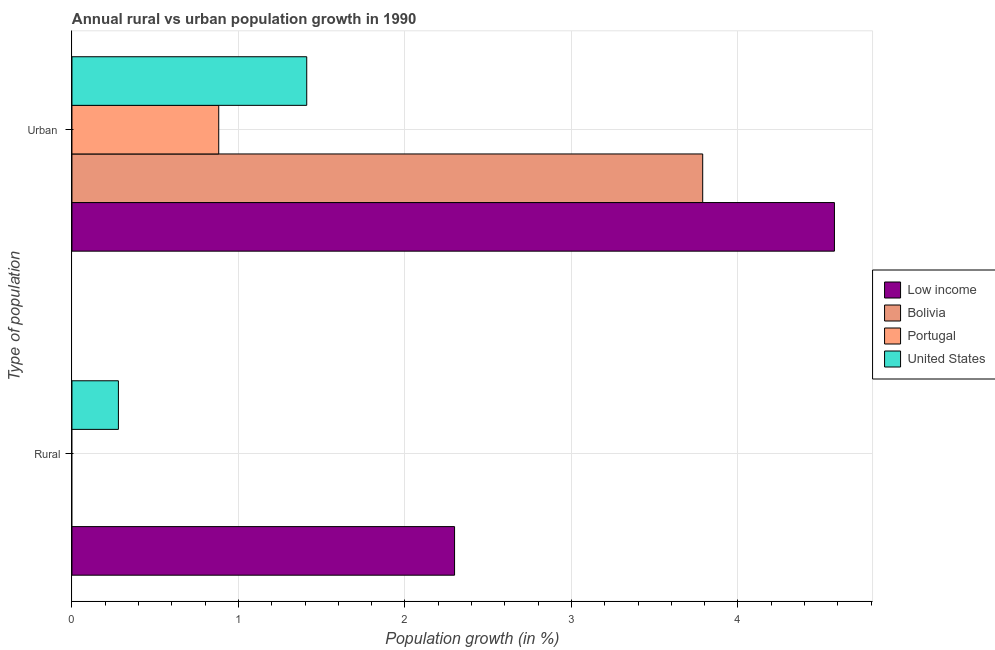Are the number of bars per tick equal to the number of legend labels?
Give a very brief answer. No. Are the number of bars on each tick of the Y-axis equal?
Your answer should be very brief. No. What is the label of the 1st group of bars from the top?
Provide a short and direct response. Urban . Across all countries, what is the maximum urban population growth?
Make the answer very short. 4.58. Across all countries, what is the minimum urban population growth?
Ensure brevity in your answer.  0.88. What is the total urban population growth in the graph?
Make the answer very short. 10.66. What is the difference between the urban population growth in Low income and that in Portugal?
Your answer should be very brief. 3.7. What is the difference between the rural population growth in Bolivia and the urban population growth in Portugal?
Keep it short and to the point. -0.88. What is the average rural population growth per country?
Keep it short and to the point. 0.64. What is the difference between the rural population growth and urban population growth in Low income?
Offer a terse response. -2.28. In how many countries, is the rural population growth greater than 4.4 %?
Make the answer very short. 0. What is the ratio of the urban population growth in Portugal to that in Low income?
Offer a terse response. 0.19. In how many countries, is the urban population growth greater than the average urban population growth taken over all countries?
Offer a very short reply. 2. How many bars are there?
Give a very brief answer. 6. Are all the bars in the graph horizontal?
Offer a terse response. Yes. Are the values on the major ticks of X-axis written in scientific E-notation?
Your response must be concise. No. Does the graph contain any zero values?
Your answer should be very brief. Yes. Does the graph contain grids?
Keep it short and to the point. Yes. Where does the legend appear in the graph?
Offer a very short reply. Center right. How many legend labels are there?
Provide a succinct answer. 4. What is the title of the graph?
Give a very brief answer. Annual rural vs urban population growth in 1990. Does "Eritrea" appear as one of the legend labels in the graph?
Provide a short and direct response. No. What is the label or title of the X-axis?
Your response must be concise. Population growth (in %). What is the label or title of the Y-axis?
Your answer should be compact. Type of population. What is the Population growth (in %) in Low income in Rural?
Ensure brevity in your answer.  2.3. What is the Population growth (in %) of Bolivia in Rural?
Offer a very short reply. 0. What is the Population growth (in %) of United States in Rural?
Your answer should be compact. 0.28. What is the Population growth (in %) of Low income in Urban ?
Your answer should be very brief. 4.58. What is the Population growth (in %) of Bolivia in Urban ?
Provide a succinct answer. 3.79. What is the Population growth (in %) in Portugal in Urban ?
Make the answer very short. 0.88. What is the Population growth (in %) in United States in Urban ?
Your answer should be very brief. 1.41. Across all Type of population, what is the maximum Population growth (in %) of Low income?
Your answer should be very brief. 4.58. Across all Type of population, what is the maximum Population growth (in %) of Bolivia?
Provide a succinct answer. 3.79. Across all Type of population, what is the maximum Population growth (in %) in Portugal?
Offer a very short reply. 0.88. Across all Type of population, what is the maximum Population growth (in %) in United States?
Offer a terse response. 1.41. Across all Type of population, what is the minimum Population growth (in %) of Low income?
Keep it short and to the point. 2.3. Across all Type of population, what is the minimum Population growth (in %) in Bolivia?
Provide a short and direct response. 0. Across all Type of population, what is the minimum Population growth (in %) in Portugal?
Offer a terse response. 0. Across all Type of population, what is the minimum Population growth (in %) of United States?
Provide a short and direct response. 0.28. What is the total Population growth (in %) in Low income in the graph?
Keep it short and to the point. 6.88. What is the total Population growth (in %) of Bolivia in the graph?
Your response must be concise. 3.79. What is the total Population growth (in %) in Portugal in the graph?
Provide a short and direct response. 0.88. What is the total Population growth (in %) in United States in the graph?
Keep it short and to the point. 1.69. What is the difference between the Population growth (in %) in Low income in Rural and that in Urban ?
Provide a succinct answer. -2.28. What is the difference between the Population growth (in %) of United States in Rural and that in Urban ?
Give a very brief answer. -1.13. What is the difference between the Population growth (in %) of Low income in Rural and the Population growth (in %) of Bolivia in Urban ?
Give a very brief answer. -1.49. What is the difference between the Population growth (in %) of Low income in Rural and the Population growth (in %) of Portugal in Urban ?
Offer a very short reply. 1.42. What is the difference between the Population growth (in %) in Low income in Rural and the Population growth (in %) in United States in Urban ?
Provide a short and direct response. 0.89. What is the average Population growth (in %) in Low income per Type of population?
Offer a terse response. 3.44. What is the average Population growth (in %) in Bolivia per Type of population?
Ensure brevity in your answer.  1.89. What is the average Population growth (in %) of Portugal per Type of population?
Offer a terse response. 0.44. What is the average Population growth (in %) in United States per Type of population?
Make the answer very short. 0.84. What is the difference between the Population growth (in %) of Low income and Population growth (in %) of United States in Rural?
Provide a succinct answer. 2.02. What is the difference between the Population growth (in %) of Low income and Population growth (in %) of Bolivia in Urban ?
Your response must be concise. 0.79. What is the difference between the Population growth (in %) in Low income and Population growth (in %) in Portugal in Urban ?
Your answer should be compact. 3.7. What is the difference between the Population growth (in %) of Low income and Population growth (in %) of United States in Urban ?
Offer a very short reply. 3.17. What is the difference between the Population growth (in %) of Bolivia and Population growth (in %) of Portugal in Urban ?
Offer a terse response. 2.91. What is the difference between the Population growth (in %) of Bolivia and Population growth (in %) of United States in Urban ?
Give a very brief answer. 2.38. What is the difference between the Population growth (in %) of Portugal and Population growth (in %) of United States in Urban ?
Ensure brevity in your answer.  -0.53. What is the ratio of the Population growth (in %) of Low income in Rural to that in Urban ?
Keep it short and to the point. 0.5. What is the ratio of the Population growth (in %) in United States in Rural to that in Urban ?
Your answer should be compact. 0.2. What is the difference between the highest and the second highest Population growth (in %) in Low income?
Provide a short and direct response. 2.28. What is the difference between the highest and the second highest Population growth (in %) in United States?
Keep it short and to the point. 1.13. What is the difference between the highest and the lowest Population growth (in %) in Low income?
Your answer should be very brief. 2.28. What is the difference between the highest and the lowest Population growth (in %) of Bolivia?
Offer a terse response. 3.79. What is the difference between the highest and the lowest Population growth (in %) of Portugal?
Your answer should be very brief. 0.88. What is the difference between the highest and the lowest Population growth (in %) of United States?
Ensure brevity in your answer.  1.13. 